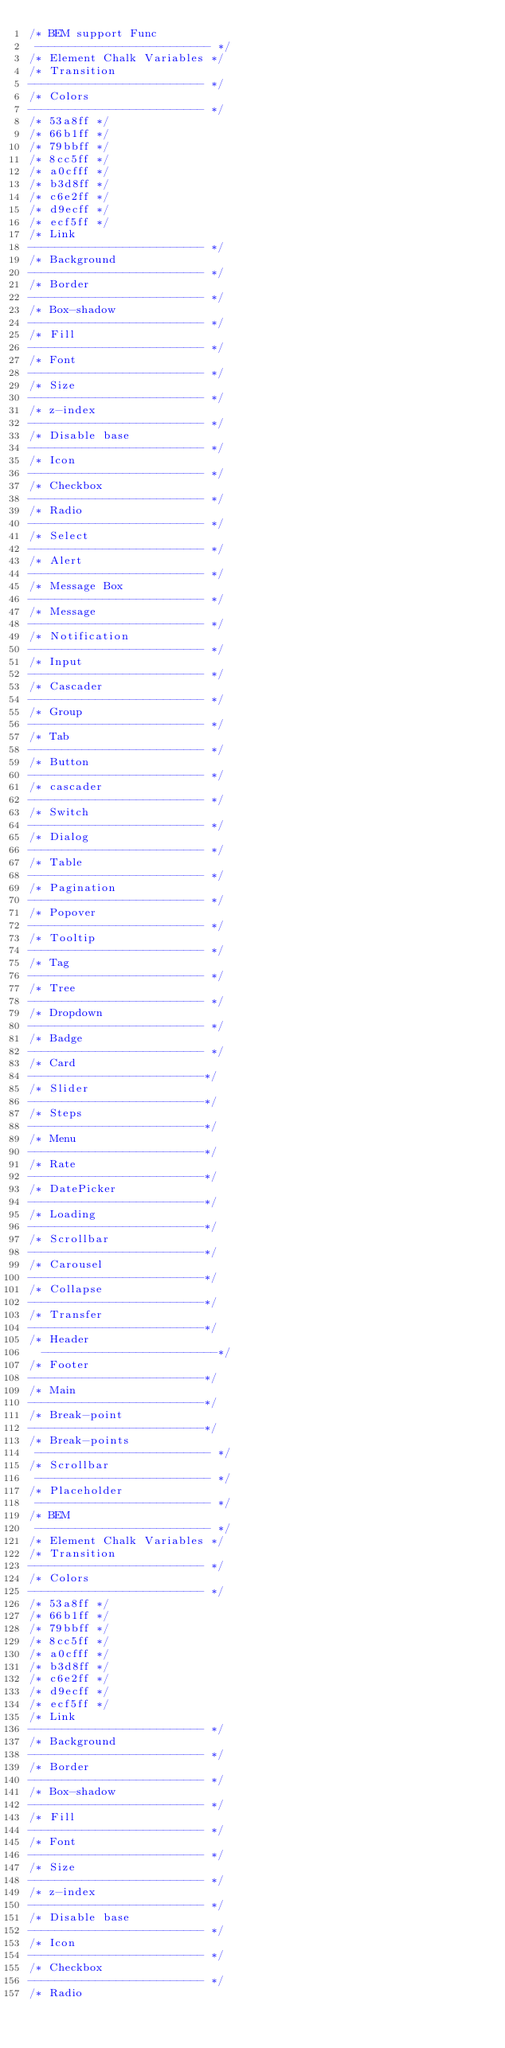Convert code to text. <code><loc_0><loc_0><loc_500><loc_500><_CSS_>/* BEM support Func
 -------------------------- */
/* Element Chalk Variables */
/* Transition
-------------------------- */
/* Colors
-------------------------- */
/* 53a8ff */
/* 66b1ff */
/* 79bbff */
/* 8cc5ff */
/* a0cfff */
/* b3d8ff */
/* c6e2ff */
/* d9ecff */
/* ecf5ff */
/* Link
-------------------------- */
/* Background
-------------------------- */
/* Border
-------------------------- */
/* Box-shadow
-------------------------- */
/* Fill
-------------------------- */
/* Font
-------------------------- */
/* Size
-------------------------- */
/* z-index
-------------------------- */
/* Disable base
-------------------------- */
/* Icon
-------------------------- */
/* Checkbox
-------------------------- */
/* Radio
-------------------------- */
/* Select
-------------------------- */
/* Alert
-------------------------- */
/* Message Box
-------------------------- */
/* Message
-------------------------- */
/* Notification
-------------------------- */
/* Input
-------------------------- */
/* Cascader
-------------------------- */
/* Group
-------------------------- */
/* Tab
-------------------------- */
/* Button
-------------------------- */
/* cascader
-------------------------- */
/* Switch
-------------------------- */
/* Dialog
-------------------------- */
/* Table
-------------------------- */
/* Pagination
-------------------------- */
/* Popover
-------------------------- */
/* Tooltip
-------------------------- */
/* Tag
-------------------------- */
/* Tree
-------------------------- */
/* Dropdown
-------------------------- */
/* Badge
-------------------------- */
/* Card
--------------------------*/
/* Slider
--------------------------*/
/* Steps
--------------------------*/
/* Menu
--------------------------*/
/* Rate
--------------------------*/
/* DatePicker
--------------------------*/
/* Loading
--------------------------*/
/* Scrollbar
--------------------------*/
/* Carousel
--------------------------*/
/* Collapse
--------------------------*/
/* Transfer
--------------------------*/
/* Header
  --------------------------*/
/* Footer
--------------------------*/
/* Main
--------------------------*/
/* Break-point
--------------------------*/
/* Break-points
 -------------------------- */
/* Scrollbar
 -------------------------- */
/* Placeholder
 -------------------------- */
/* BEM
 -------------------------- */
/* Element Chalk Variables */
/* Transition
-------------------------- */
/* Colors
-------------------------- */
/* 53a8ff */
/* 66b1ff */
/* 79bbff */
/* 8cc5ff */
/* a0cfff */
/* b3d8ff */
/* c6e2ff */
/* d9ecff */
/* ecf5ff */
/* Link
-------------------------- */
/* Background
-------------------------- */
/* Border
-------------------------- */
/* Box-shadow
-------------------------- */
/* Fill
-------------------------- */
/* Font
-------------------------- */
/* Size
-------------------------- */
/* z-index
-------------------------- */
/* Disable base
-------------------------- */
/* Icon
-------------------------- */
/* Checkbox
-------------------------- */
/* Radio</code> 